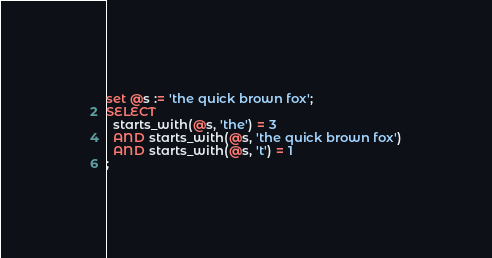Convert code to text. <code><loc_0><loc_0><loc_500><loc_500><_SQL_>set @s := 'the quick brown fox';
SELECT 
  starts_with(@s, 'the') = 3
  AND starts_with(@s, 'the quick brown fox')
  AND starts_with(@s, 't') = 1
;
</code> 